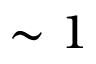<formula> <loc_0><loc_0><loc_500><loc_500>\sim 1</formula> 